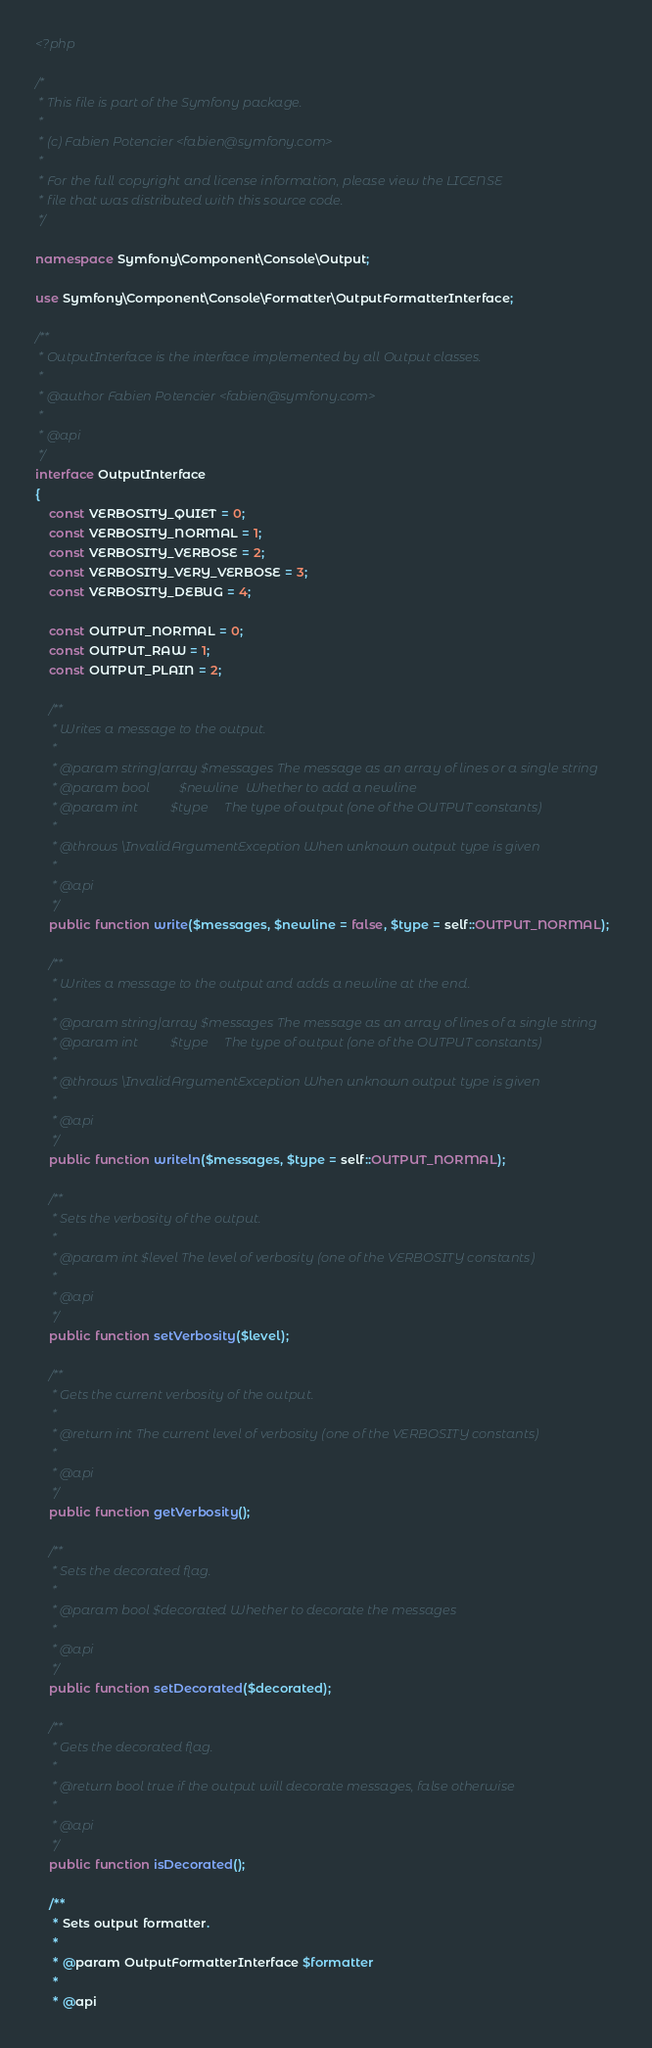<code> <loc_0><loc_0><loc_500><loc_500><_PHP_><?php

/*
 * This file is part of the Symfony package.
 *
 * (c) Fabien Potencier <fabien@symfony.com>
 *
 * For the full copyright and license information, please view the LICENSE
 * file that was distributed with this source code.
 */

namespace Symfony\Component\Console\Output;

use Symfony\Component\Console\Formatter\OutputFormatterInterface;

/**
 * OutputInterface is the interface implemented by all Output classes.
 *
 * @author Fabien Potencier <fabien@symfony.com>
 *
 * @api
 */
interface OutputInterface
{
    const VERBOSITY_QUIET = 0;
    const VERBOSITY_NORMAL = 1;
    const VERBOSITY_VERBOSE = 2;
    const VERBOSITY_VERY_VERBOSE = 3;
    const VERBOSITY_DEBUG = 4;

    const OUTPUT_NORMAL = 0;
    const OUTPUT_RAW = 1;
    const OUTPUT_PLAIN = 2;

    /**
     * Writes a message to the output.
     *
     * @param string|array $messages The message as an array of lines or a single string
     * @param bool         $newline  Whether to add a newline
     * @param int          $type     The type of output (one of the OUTPUT constants)
     *
     * @throws \InvalidArgumentException When unknown output type is given
     *
     * @api
     */
    public function write($messages, $newline = false, $type = self::OUTPUT_NORMAL);

    /**
     * Writes a message to the output and adds a newline at the end.
     *
     * @param string|array $messages The message as an array of lines of a single string
     * @param int          $type     The type of output (one of the OUTPUT constants)
     *
     * @throws \InvalidArgumentException When unknown output type is given
     *
     * @api
     */
    public function writeln($messages, $type = self::OUTPUT_NORMAL);

    /**
     * Sets the verbosity of the output.
     *
     * @param int $level The level of verbosity (one of the VERBOSITY constants)
     *
     * @api
     */
    public function setVerbosity($level);

    /**
     * Gets the current verbosity of the output.
     *
     * @return int The current level of verbosity (one of the VERBOSITY constants)
     *
     * @api
     */
    public function getVerbosity();

    /**
     * Sets the decorated flag.
     *
     * @param bool $decorated Whether to decorate the messages
     *
     * @api
     */
    public function setDecorated($decorated);

    /**
     * Gets the decorated flag.
     *
     * @return bool true if the output will decorate messages, false otherwise
     *
     * @api
     */
    public function isDecorated();

    /**
     * Sets output formatter.
     *
     * @param OutputFormatterInterface $formatter
     *
     * @api</code> 